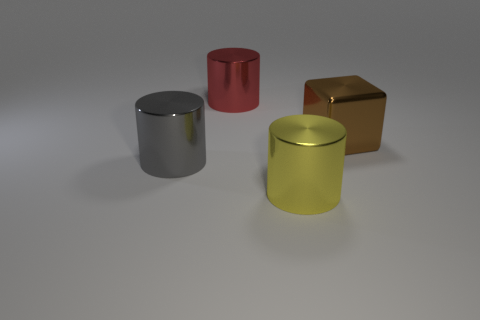What number of big gray things are there?
Offer a terse response. 1. What number of objects have the same size as the gray cylinder?
Your answer should be very brief. 3. What material is the large object that is both on the right side of the big red thing and behind the gray shiny cylinder?
Your response must be concise. Metal. There is a red object that is the same material as the yellow object; what size is it?
Your answer should be very brief. Large. Is the size of the red cylinder the same as the gray shiny thing that is in front of the large block?
Offer a very short reply. Yes. What shape is the metallic thing right of the yellow shiny object?
Offer a terse response. Cube. Are there any big cylinders on the left side of the shiny cylinder that is behind the shiny object that is on the right side of the big yellow object?
Offer a terse response. Yes. What number of cylinders are gray metal things or red things?
Ensure brevity in your answer.  2. Are there fewer large red shiny objects that are to the right of the big brown thing than red metallic cylinders?
Offer a very short reply. Yes. What shape is the big brown thing that is made of the same material as the red cylinder?
Your answer should be very brief. Cube. 